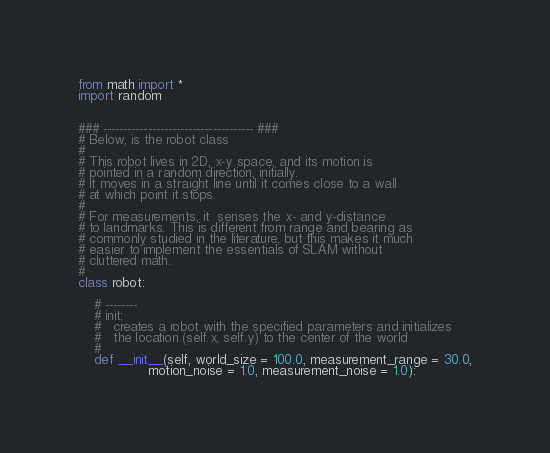<code> <loc_0><loc_0><loc_500><loc_500><_Python_>from math import *
import random


### ------------------------------------- ###
# Below, is the robot class
#
# This robot lives in 2D, x-y space, and its motion is
# pointed in a random direction, initially.
# It moves in a straight line until it comes close to a wall 
# at which point it stops.
#
# For measurements, it  senses the x- and y-distance
# to landmarks. This is different from range and bearing as
# commonly studied in the literature, but this makes it much
# easier to implement the essentials of SLAM without
# cluttered math.
#
class robot:
    
    # --------
    # init:
    #   creates a robot with the specified parameters and initializes
    #   the location (self.x, self.y) to the center of the world
    #
    def __init__(self, world_size = 100.0, measurement_range = 30.0,
                 motion_noise = 1.0, measurement_noise = 1.0):</code> 